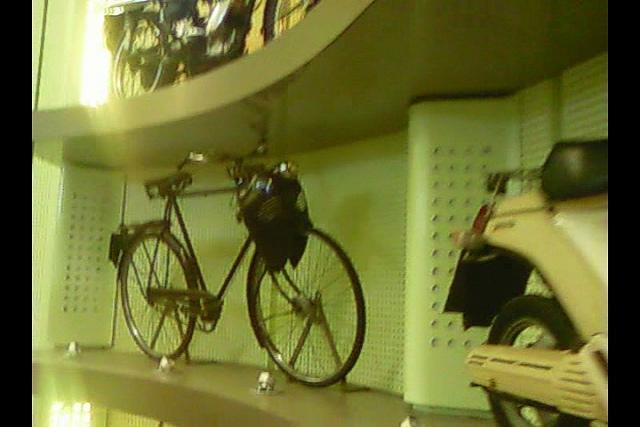What mode of transportation is featured?
Choose the correct response and explain in the format: 'Answer: answer
Rationale: rationale.'
Options: Bike, car, bus, train. Answer: bike.
Rationale: The transportation is a bike. 